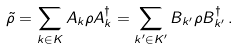<formula> <loc_0><loc_0><loc_500><loc_500>\tilde { \rho } = \sum _ { k \in K } A _ { k } \rho A _ { k } ^ { \dagger } = \sum _ { k ^ { \prime } \in K ^ { \prime } } B _ { k ^ { \prime } } \rho B _ { k ^ { \prime } } ^ { \dagger } \, .</formula> 